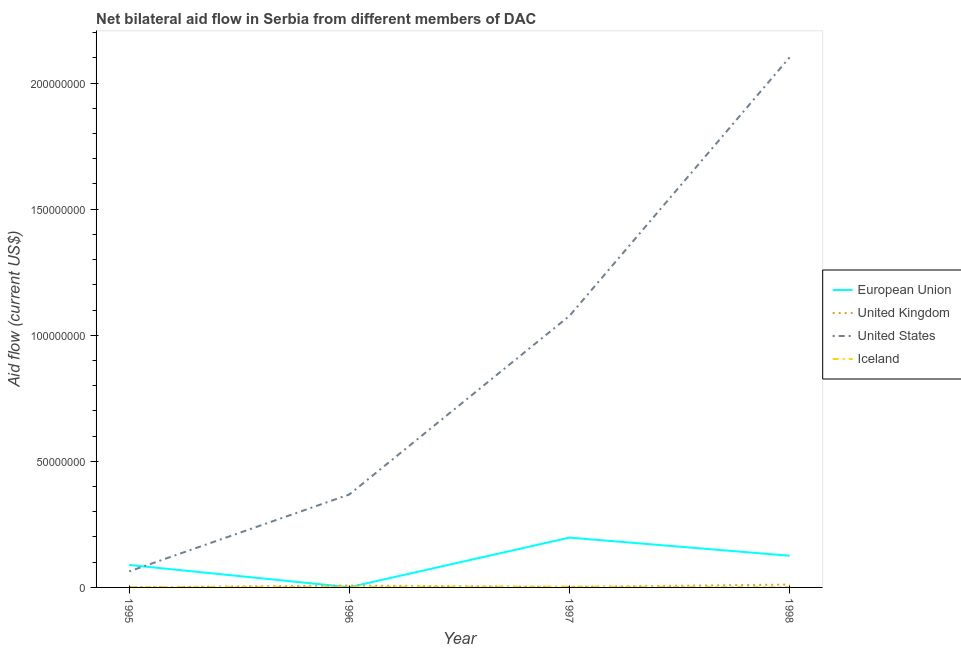Is the number of lines equal to the number of legend labels?
Your answer should be very brief. Yes. What is the amount of aid given by eu in 1998?
Provide a succinct answer. 1.26e+07. Across all years, what is the maximum amount of aid given by uk?
Your response must be concise. 1.13e+06. Across all years, what is the minimum amount of aid given by iceland?
Give a very brief answer. 7.00e+04. What is the total amount of aid given by uk in the graph?
Provide a succinct answer. 2.13e+06. What is the difference between the amount of aid given by eu in 1996 and that in 1998?
Offer a terse response. -1.25e+07. What is the difference between the amount of aid given by us in 1997 and the amount of aid given by uk in 1998?
Keep it short and to the point. 1.07e+08. What is the average amount of aid given by us per year?
Your answer should be compact. 9.03e+07. In the year 1996, what is the difference between the amount of aid given by us and amount of aid given by iceland?
Provide a short and direct response. 3.66e+07. In how many years, is the amount of aid given by iceland greater than 50000000 US$?
Keep it short and to the point. 0. What is the ratio of the amount of aid given by uk in 1996 to that in 1997?
Your answer should be compact. 3.57. Is the amount of aid given by eu in 1996 less than that in 1998?
Make the answer very short. Yes. What is the difference between the highest and the second highest amount of aid given by iceland?
Your response must be concise. 1.00e+05. What is the difference between the highest and the lowest amount of aid given by eu?
Your response must be concise. 1.97e+07. In how many years, is the amount of aid given by eu greater than the average amount of aid given by eu taken over all years?
Give a very brief answer. 2. Is the sum of the amount of aid given by uk in 1996 and 1997 greater than the maximum amount of aid given by eu across all years?
Ensure brevity in your answer.  No. Is it the case that in every year, the sum of the amount of aid given by uk and amount of aid given by iceland is greater than the sum of amount of aid given by us and amount of aid given by eu?
Your response must be concise. No. Is it the case that in every year, the sum of the amount of aid given by eu and amount of aid given by uk is greater than the amount of aid given by us?
Ensure brevity in your answer.  No. Does the amount of aid given by uk monotonically increase over the years?
Provide a succinct answer. No. Is the amount of aid given by iceland strictly greater than the amount of aid given by uk over the years?
Make the answer very short. No. Is the amount of aid given by eu strictly less than the amount of aid given by uk over the years?
Your answer should be very brief. No. How many years are there in the graph?
Provide a succinct answer. 4. Are the values on the major ticks of Y-axis written in scientific E-notation?
Provide a short and direct response. No. Where does the legend appear in the graph?
Your answer should be compact. Center right. How are the legend labels stacked?
Provide a short and direct response. Vertical. What is the title of the graph?
Make the answer very short. Net bilateral aid flow in Serbia from different members of DAC. Does "Switzerland" appear as one of the legend labels in the graph?
Your answer should be very brief. No. What is the label or title of the X-axis?
Your answer should be very brief. Year. What is the label or title of the Y-axis?
Give a very brief answer. Aid flow (current US$). What is the Aid flow (current US$) of European Union in 1995?
Provide a short and direct response. 8.90e+06. What is the Aid flow (current US$) of United States in 1995?
Ensure brevity in your answer.  6.36e+06. What is the Aid flow (current US$) of United Kingdom in 1996?
Your answer should be very brief. 7.50e+05. What is the Aid flow (current US$) of United States in 1996?
Provide a succinct answer. 3.69e+07. What is the Aid flow (current US$) in European Union in 1997?
Your answer should be very brief. 1.98e+07. What is the Aid flow (current US$) of United Kingdom in 1997?
Keep it short and to the point. 2.10e+05. What is the Aid flow (current US$) in United States in 1997?
Give a very brief answer. 1.08e+08. What is the Aid flow (current US$) of European Union in 1998?
Make the answer very short. 1.26e+07. What is the Aid flow (current US$) of United Kingdom in 1998?
Provide a short and direct response. 1.13e+06. What is the Aid flow (current US$) in United States in 1998?
Ensure brevity in your answer.  2.10e+08. Across all years, what is the maximum Aid flow (current US$) of European Union?
Make the answer very short. 1.98e+07. Across all years, what is the maximum Aid flow (current US$) in United Kingdom?
Your answer should be very brief. 1.13e+06. Across all years, what is the maximum Aid flow (current US$) in United States?
Your answer should be compact. 2.10e+08. Across all years, what is the minimum Aid flow (current US$) in European Union?
Keep it short and to the point. 9.00e+04. Across all years, what is the minimum Aid flow (current US$) of United States?
Ensure brevity in your answer.  6.36e+06. What is the total Aid flow (current US$) of European Union in the graph?
Make the answer very short. 4.13e+07. What is the total Aid flow (current US$) of United Kingdom in the graph?
Keep it short and to the point. 2.13e+06. What is the total Aid flow (current US$) of United States in the graph?
Keep it short and to the point. 3.61e+08. What is the total Aid flow (current US$) of Iceland in the graph?
Your answer should be compact. 7.90e+05. What is the difference between the Aid flow (current US$) of European Union in 1995 and that in 1996?
Offer a terse response. 8.81e+06. What is the difference between the Aid flow (current US$) in United Kingdom in 1995 and that in 1996?
Make the answer very short. -7.10e+05. What is the difference between the Aid flow (current US$) in United States in 1995 and that in 1996?
Your answer should be compact. -3.05e+07. What is the difference between the Aid flow (current US$) of European Union in 1995 and that in 1997?
Your answer should be compact. -1.09e+07. What is the difference between the Aid flow (current US$) in United States in 1995 and that in 1997?
Provide a succinct answer. -1.01e+08. What is the difference between the Aid flow (current US$) of Iceland in 1995 and that in 1997?
Provide a succinct answer. -1.40e+05. What is the difference between the Aid flow (current US$) in European Union in 1995 and that in 1998?
Your response must be concise. -3.66e+06. What is the difference between the Aid flow (current US$) in United Kingdom in 1995 and that in 1998?
Make the answer very short. -1.09e+06. What is the difference between the Aid flow (current US$) of United States in 1995 and that in 1998?
Provide a succinct answer. -2.04e+08. What is the difference between the Aid flow (current US$) in Iceland in 1995 and that in 1998?
Offer a terse response. 1.10e+05. What is the difference between the Aid flow (current US$) of European Union in 1996 and that in 1997?
Make the answer very short. -1.97e+07. What is the difference between the Aid flow (current US$) of United Kingdom in 1996 and that in 1997?
Provide a short and direct response. 5.40e+05. What is the difference between the Aid flow (current US$) in United States in 1996 and that in 1997?
Provide a short and direct response. -7.08e+07. What is the difference between the Aid flow (current US$) in European Union in 1996 and that in 1998?
Your answer should be compact. -1.25e+07. What is the difference between the Aid flow (current US$) of United Kingdom in 1996 and that in 1998?
Provide a succinct answer. -3.80e+05. What is the difference between the Aid flow (current US$) in United States in 1996 and that in 1998?
Keep it short and to the point. -1.73e+08. What is the difference between the Aid flow (current US$) in Iceland in 1996 and that in 1998?
Offer a very short reply. 1.50e+05. What is the difference between the Aid flow (current US$) in European Union in 1997 and that in 1998?
Provide a short and direct response. 7.20e+06. What is the difference between the Aid flow (current US$) in United Kingdom in 1997 and that in 1998?
Offer a terse response. -9.20e+05. What is the difference between the Aid flow (current US$) of United States in 1997 and that in 1998?
Make the answer very short. -1.03e+08. What is the difference between the Aid flow (current US$) in European Union in 1995 and the Aid flow (current US$) in United Kingdom in 1996?
Give a very brief answer. 8.15e+06. What is the difference between the Aid flow (current US$) in European Union in 1995 and the Aid flow (current US$) in United States in 1996?
Keep it short and to the point. -2.80e+07. What is the difference between the Aid flow (current US$) in European Union in 1995 and the Aid flow (current US$) in Iceland in 1996?
Provide a succinct answer. 8.68e+06. What is the difference between the Aid flow (current US$) of United Kingdom in 1995 and the Aid flow (current US$) of United States in 1996?
Your answer should be very brief. -3.68e+07. What is the difference between the Aid flow (current US$) of United States in 1995 and the Aid flow (current US$) of Iceland in 1996?
Ensure brevity in your answer.  6.14e+06. What is the difference between the Aid flow (current US$) in European Union in 1995 and the Aid flow (current US$) in United Kingdom in 1997?
Offer a terse response. 8.69e+06. What is the difference between the Aid flow (current US$) in European Union in 1995 and the Aid flow (current US$) in United States in 1997?
Provide a succinct answer. -9.88e+07. What is the difference between the Aid flow (current US$) of European Union in 1995 and the Aid flow (current US$) of Iceland in 1997?
Give a very brief answer. 8.58e+06. What is the difference between the Aid flow (current US$) in United Kingdom in 1995 and the Aid flow (current US$) in United States in 1997?
Provide a short and direct response. -1.08e+08. What is the difference between the Aid flow (current US$) in United Kingdom in 1995 and the Aid flow (current US$) in Iceland in 1997?
Provide a short and direct response. -2.80e+05. What is the difference between the Aid flow (current US$) in United States in 1995 and the Aid flow (current US$) in Iceland in 1997?
Offer a terse response. 6.04e+06. What is the difference between the Aid flow (current US$) in European Union in 1995 and the Aid flow (current US$) in United Kingdom in 1998?
Keep it short and to the point. 7.77e+06. What is the difference between the Aid flow (current US$) in European Union in 1995 and the Aid flow (current US$) in United States in 1998?
Ensure brevity in your answer.  -2.01e+08. What is the difference between the Aid flow (current US$) of European Union in 1995 and the Aid flow (current US$) of Iceland in 1998?
Give a very brief answer. 8.83e+06. What is the difference between the Aid flow (current US$) of United Kingdom in 1995 and the Aid flow (current US$) of United States in 1998?
Your response must be concise. -2.10e+08. What is the difference between the Aid flow (current US$) of United Kingdom in 1995 and the Aid flow (current US$) of Iceland in 1998?
Keep it short and to the point. -3.00e+04. What is the difference between the Aid flow (current US$) in United States in 1995 and the Aid flow (current US$) in Iceland in 1998?
Your answer should be compact. 6.29e+06. What is the difference between the Aid flow (current US$) of European Union in 1996 and the Aid flow (current US$) of United States in 1997?
Give a very brief answer. -1.08e+08. What is the difference between the Aid flow (current US$) of European Union in 1996 and the Aid flow (current US$) of Iceland in 1997?
Keep it short and to the point. -2.30e+05. What is the difference between the Aid flow (current US$) in United Kingdom in 1996 and the Aid flow (current US$) in United States in 1997?
Provide a succinct answer. -1.07e+08. What is the difference between the Aid flow (current US$) in United States in 1996 and the Aid flow (current US$) in Iceland in 1997?
Your response must be concise. 3.66e+07. What is the difference between the Aid flow (current US$) in European Union in 1996 and the Aid flow (current US$) in United Kingdom in 1998?
Your answer should be very brief. -1.04e+06. What is the difference between the Aid flow (current US$) in European Union in 1996 and the Aid flow (current US$) in United States in 1998?
Your response must be concise. -2.10e+08. What is the difference between the Aid flow (current US$) in United Kingdom in 1996 and the Aid flow (current US$) in United States in 1998?
Your answer should be very brief. -2.09e+08. What is the difference between the Aid flow (current US$) of United Kingdom in 1996 and the Aid flow (current US$) of Iceland in 1998?
Provide a succinct answer. 6.80e+05. What is the difference between the Aid flow (current US$) in United States in 1996 and the Aid flow (current US$) in Iceland in 1998?
Provide a succinct answer. 3.68e+07. What is the difference between the Aid flow (current US$) in European Union in 1997 and the Aid flow (current US$) in United Kingdom in 1998?
Give a very brief answer. 1.86e+07. What is the difference between the Aid flow (current US$) in European Union in 1997 and the Aid flow (current US$) in United States in 1998?
Offer a terse response. -1.90e+08. What is the difference between the Aid flow (current US$) in European Union in 1997 and the Aid flow (current US$) in Iceland in 1998?
Offer a very short reply. 1.97e+07. What is the difference between the Aid flow (current US$) in United Kingdom in 1997 and the Aid flow (current US$) in United States in 1998?
Offer a terse response. -2.10e+08. What is the difference between the Aid flow (current US$) of United Kingdom in 1997 and the Aid flow (current US$) of Iceland in 1998?
Give a very brief answer. 1.40e+05. What is the difference between the Aid flow (current US$) in United States in 1997 and the Aid flow (current US$) in Iceland in 1998?
Provide a short and direct response. 1.08e+08. What is the average Aid flow (current US$) of European Union per year?
Give a very brief answer. 1.03e+07. What is the average Aid flow (current US$) of United Kingdom per year?
Your response must be concise. 5.32e+05. What is the average Aid flow (current US$) in United States per year?
Your answer should be very brief. 9.03e+07. What is the average Aid flow (current US$) of Iceland per year?
Offer a very short reply. 1.98e+05. In the year 1995, what is the difference between the Aid flow (current US$) in European Union and Aid flow (current US$) in United Kingdom?
Offer a terse response. 8.86e+06. In the year 1995, what is the difference between the Aid flow (current US$) in European Union and Aid flow (current US$) in United States?
Give a very brief answer. 2.54e+06. In the year 1995, what is the difference between the Aid flow (current US$) in European Union and Aid flow (current US$) in Iceland?
Make the answer very short. 8.72e+06. In the year 1995, what is the difference between the Aid flow (current US$) in United Kingdom and Aid flow (current US$) in United States?
Your answer should be compact. -6.32e+06. In the year 1995, what is the difference between the Aid flow (current US$) of United Kingdom and Aid flow (current US$) of Iceland?
Offer a terse response. -1.40e+05. In the year 1995, what is the difference between the Aid flow (current US$) in United States and Aid flow (current US$) in Iceland?
Provide a succinct answer. 6.18e+06. In the year 1996, what is the difference between the Aid flow (current US$) of European Union and Aid flow (current US$) of United Kingdom?
Ensure brevity in your answer.  -6.60e+05. In the year 1996, what is the difference between the Aid flow (current US$) of European Union and Aid flow (current US$) of United States?
Your response must be concise. -3.68e+07. In the year 1996, what is the difference between the Aid flow (current US$) in United Kingdom and Aid flow (current US$) in United States?
Provide a succinct answer. -3.61e+07. In the year 1996, what is the difference between the Aid flow (current US$) of United Kingdom and Aid flow (current US$) of Iceland?
Offer a very short reply. 5.30e+05. In the year 1996, what is the difference between the Aid flow (current US$) of United States and Aid flow (current US$) of Iceland?
Offer a terse response. 3.66e+07. In the year 1997, what is the difference between the Aid flow (current US$) of European Union and Aid flow (current US$) of United Kingdom?
Offer a terse response. 1.96e+07. In the year 1997, what is the difference between the Aid flow (current US$) of European Union and Aid flow (current US$) of United States?
Provide a short and direct response. -8.79e+07. In the year 1997, what is the difference between the Aid flow (current US$) of European Union and Aid flow (current US$) of Iceland?
Offer a very short reply. 1.94e+07. In the year 1997, what is the difference between the Aid flow (current US$) in United Kingdom and Aid flow (current US$) in United States?
Keep it short and to the point. -1.07e+08. In the year 1997, what is the difference between the Aid flow (current US$) in United States and Aid flow (current US$) in Iceland?
Your answer should be compact. 1.07e+08. In the year 1998, what is the difference between the Aid flow (current US$) of European Union and Aid flow (current US$) of United Kingdom?
Your response must be concise. 1.14e+07. In the year 1998, what is the difference between the Aid flow (current US$) in European Union and Aid flow (current US$) in United States?
Make the answer very short. -1.98e+08. In the year 1998, what is the difference between the Aid flow (current US$) in European Union and Aid flow (current US$) in Iceland?
Provide a succinct answer. 1.25e+07. In the year 1998, what is the difference between the Aid flow (current US$) of United Kingdom and Aid flow (current US$) of United States?
Give a very brief answer. -2.09e+08. In the year 1998, what is the difference between the Aid flow (current US$) of United Kingdom and Aid flow (current US$) of Iceland?
Give a very brief answer. 1.06e+06. In the year 1998, what is the difference between the Aid flow (current US$) of United States and Aid flow (current US$) of Iceland?
Offer a very short reply. 2.10e+08. What is the ratio of the Aid flow (current US$) in European Union in 1995 to that in 1996?
Your response must be concise. 98.89. What is the ratio of the Aid flow (current US$) of United Kingdom in 1995 to that in 1996?
Your response must be concise. 0.05. What is the ratio of the Aid flow (current US$) in United States in 1995 to that in 1996?
Provide a short and direct response. 0.17. What is the ratio of the Aid flow (current US$) of Iceland in 1995 to that in 1996?
Give a very brief answer. 0.82. What is the ratio of the Aid flow (current US$) in European Union in 1995 to that in 1997?
Provide a succinct answer. 0.45. What is the ratio of the Aid flow (current US$) in United Kingdom in 1995 to that in 1997?
Offer a terse response. 0.19. What is the ratio of the Aid flow (current US$) of United States in 1995 to that in 1997?
Offer a terse response. 0.06. What is the ratio of the Aid flow (current US$) in Iceland in 1995 to that in 1997?
Offer a terse response. 0.56. What is the ratio of the Aid flow (current US$) in European Union in 1995 to that in 1998?
Your answer should be compact. 0.71. What is the ratio of the Aid flow (current US$) in United Kingdom in 1995 to that in 1998?
Your answer should be compact. 0.04. What is the ratio of the Aid flow (current US$) of United States in 1995 to that in 1998?
Keep it short and to the point. 0.03. What is the ratio of the Aid flow (current US$) in Iceland in 1995 to that in 1998?
Provide a succinct answer. 2.57. What is the ratio of the Aid flow (current US$) of European Union in 1996 to that in 1997?
Your response must be concise. 0. What is the ratio of the Aid flow (current US$) in United Kingdom in 1996 to that in 1997?
Your answer should be very brief. 3.57. What is the ratio of the Aid flow (current US$) in United States in 1996 to that in 1997?
Provide a short and direct response. 0.34. What is the ratio of the Aid flow (current US$) of Iceland in 1996 to that in 1997?
Ensure brevity in your answer.  0.69. What is the ratio of the Aid flow (current US$) of European Union in 1996 to that in 1998?
Give a very brief answer. 0.01. What is the ratio of the Aid flow (current US$) of United Kingdom in 1996 to that in 1998?
Keep it short and to the point. 0.66. What is the ratio of the Aid flow (current US$) in United States in 1996 to that in 1998?
Keep it short and to the point. 0.18. What is the ratio of the Aid flow (current US$) in Iceland in 1996 to that in 1998?
Your answer should be compact. 3.14. What is the ratio of the Aid flow (current US$) of European Union in 1997 to that in 1998?
Your response must be concise. 1.57. What is the ratio of the Aid flow (current US$) of United Kingdom in 1997 to that in 1998?
Offer a very short reply. 0.19. What is the ratio of the Aid flow (current US$) of United States in 1997 to that in 1998?
Your answer should be very brief. 0.51. What is the ratio of the Aid flow (current US$) in Iceland in 1997 to that in 1998?
Keep it short and to the point. 4.57. What is the difference between the highest and the second highest Aid flow (current US$) of European Union?
Make the answer very short. 7.20e+06. What is the difference between the highest and the second highest Aid flow (current US$) of United Kingdom?
Provide a short and direct response. 3.80e+05. What is the difference between the highest and the second highest Aid flow (current US$) in United States?
Your answer should be compact. 1.03e+08. What is the difference between the highest and the second highest Aid flow (current US$) in Iceland?
Offer a very short reply. 1.00e+05. What is the difference between the highest and the lowest Aid flow (current US$) in European Union?
Make the answer very short. 1.97e+07. What is the difference between the highest and the lowest Aid flow (current US$) in United Kingdom?
Ensure brevity in your answer.  1.09e+06. What is the difference between the highest and the lowest Aid flow (current US$) in United States?
Offer a very short reply. 2.04e+08. What is the difference between the highest and the lowest Aid flow (current US$) in Iceland?
Your answer should be compact. 2.50e+05. 